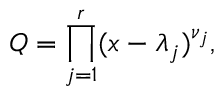Convert formula to latex. <formula><loc_0><loc_0><loc_500><loc_500>Q = \prod _ { j = 1 } ^ { r } ( x - \lambda _ { j } ) ^ { \nu _ { j } } ,</formula> 